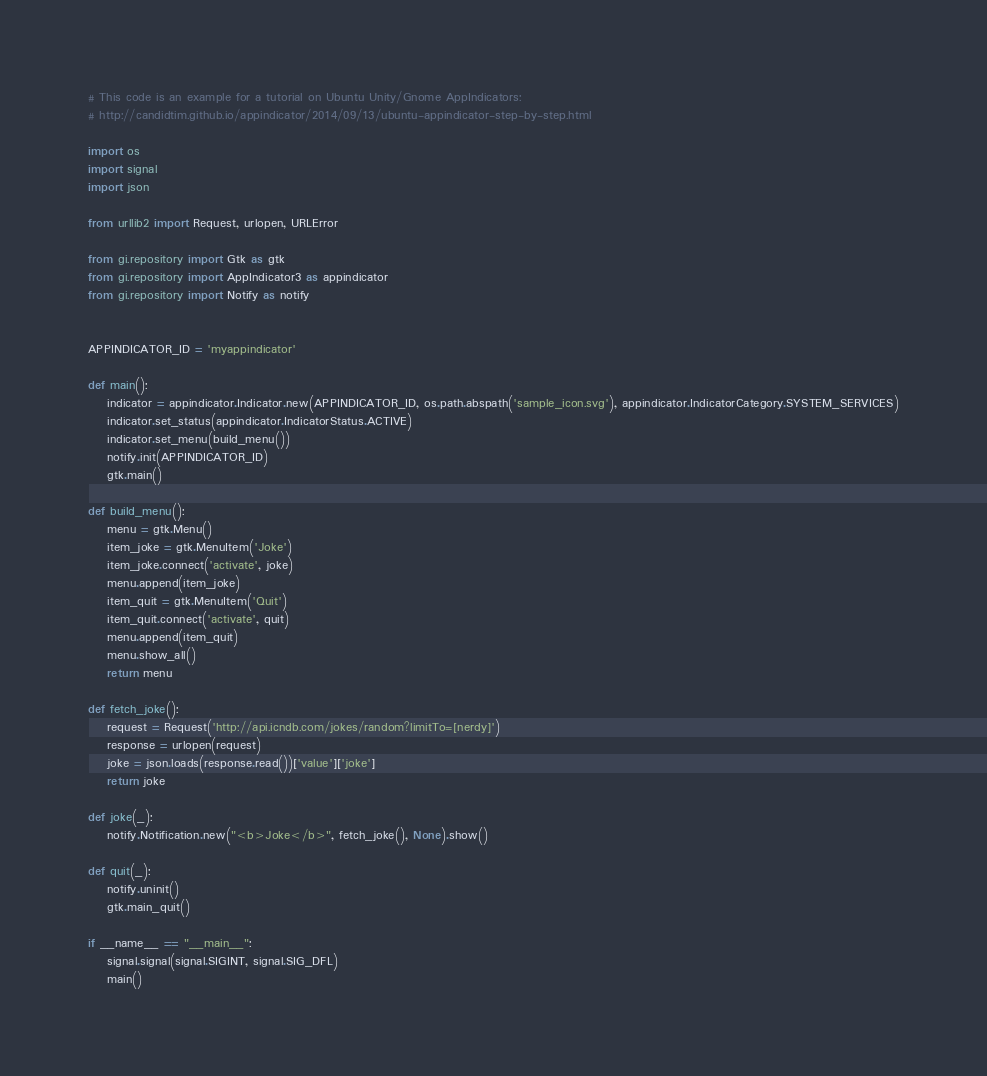Convert code to text. <code><loc_0><loc_0><loc_500><loc_500><_Python_># This code is an example for a tutorial on Ubuntu Unity/Gnome AppIndicators:
# http://candidtim.github.io/appindicator/2014/09/13/ubuntu-appindicator-step-by-step.html

import os
import signal
import json

from urllib2 import Request, urlopen, URLError

from gi.repository import Gtk as gtk
from gi.repository import AppIndicator3 as appindicator
from gi.repository import Notify as notify


APPINDICATOR_ID = 'myappindicator'

def main():
    indicator = appindicator.Indicator.new(APPINDICATOR_ID, os.path.abspath('sample_icon.svg'), appindicator.IndicatorCategory.SYSTEM_SERVICES)
    indicator.set_status(appindicator.IndicatorStatus.ACTIVE)
    indicator.set_menu(build_menu())
    notify.init(APPINDICATOR_ID)
    gtk.main()

def build_menu():
    menu = gtk.Menu()
    item_joke = gtk.MenuItem('Joke')
    item_joke.connect('activate', joke)
    menu.append(item_joke)
    item_quit = gtk.MenuItem('Quit')
    item_quit.connect('activate', quit)
    menu.append(item_quit)
    menu.show_all()
    return menu

def fetch_joke():
    request = Request('http://api.icndb.com/jokes/random?limitTo=[nerdy]')
    response = urlopen(request)
    joke = json.loads(response.read())['value']['joke']
    return joke

def joke(_):
    notify.Notification.new("<b>Joke</b>", fetch_joke(), None).show()

def quit(_):
    notify.uninit()
    gtk.main_quit()

if __name__ == "__main__":
    signal.signal(signal.SIGINT, signal.SIG_DFL)
    main()</code> 